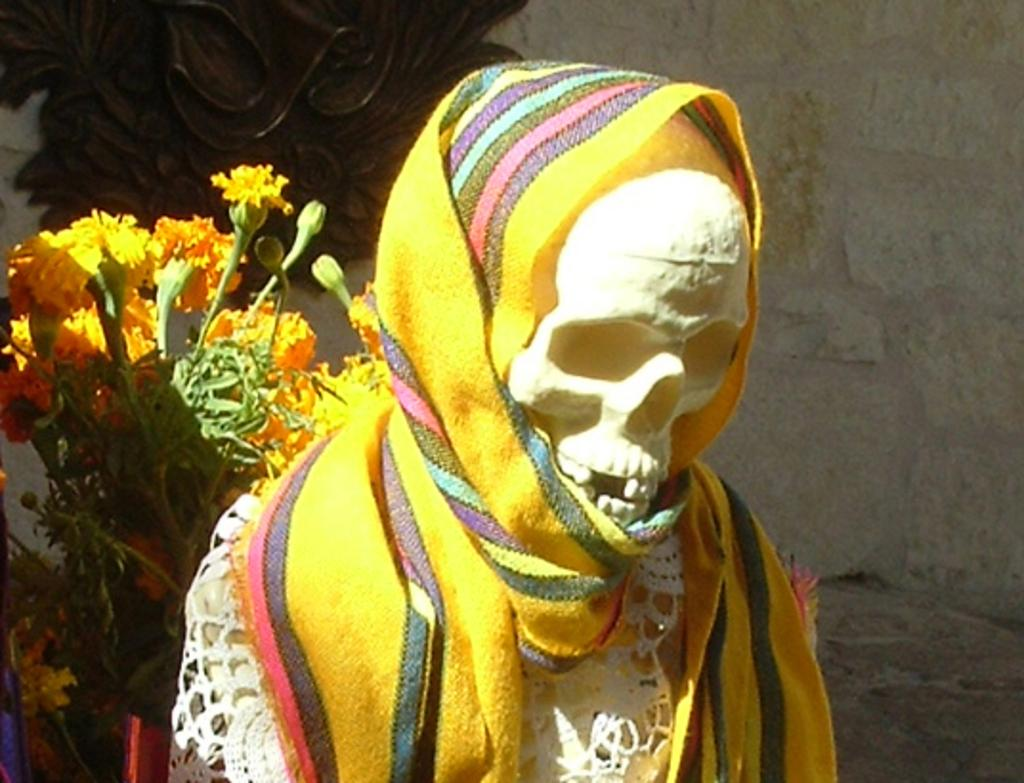What is the main subject in the image? There is a statue in the image. What other items can be seen in the image? There is cloth, flowers, buds, leaves, and unspecified objects in the image. Can you describe the background of the image? There is a wall in the background of the image. Can you describe the monkey's attempt to climb the statue in the image? There is no monkey present in the image, so it is not possible to describe any attempts to climb the statue. 